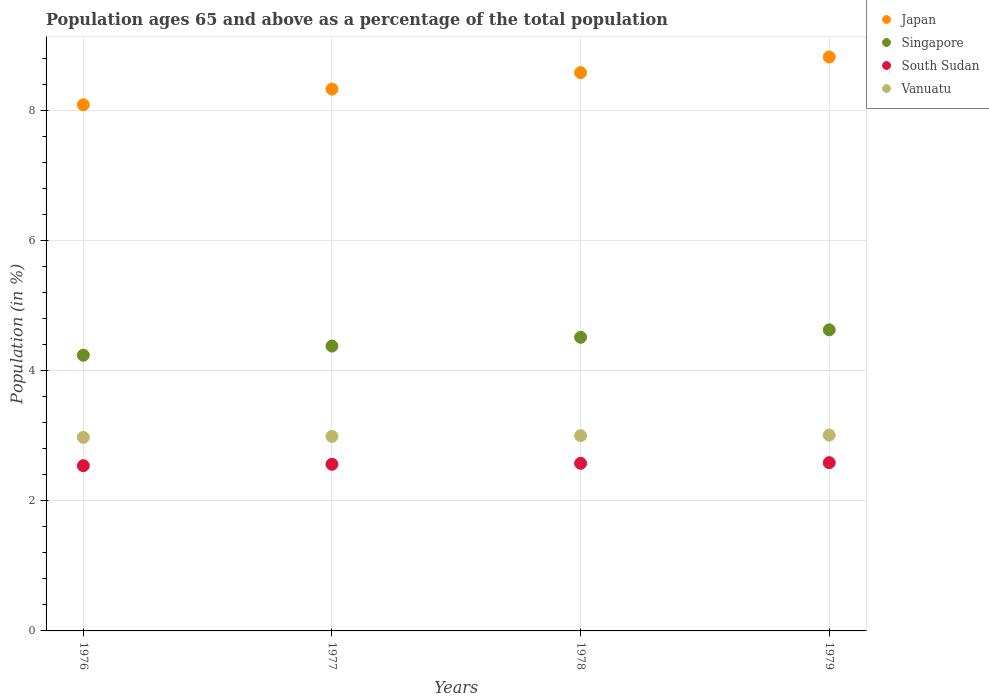How many different coloured dotlines are there?
Keep it short and to the point. 4. What is the percentage of the population ages 65 and above in Vanuatu in 1976?
Your response must be concise. 2.98. Across all years, what is the maximum percentage of the population ages 65 and above in Singapore?
Your answer should be very brief. 4.63. Across all years, what is the minimum percentage of the population ages 65 and above in Japan?
Offer a very short reply. 8.1. In which year was the percentage of the population ages 65 and above in Singapore maximum?
Provide a short and direct response. 1979. In which year was the percentage of the population ages 65 and above in Singapore minimum?
Keep it short and to the point. 1976. What is the total percentage of the population ages 65 and above in Vanuatu in the graph?
Your answer should be compact. 11.99. What is the difference between the percentage of the population ages 65 and above in Vanuatu in 1976 and that in 1977?
Keep it short and to the point. -0.01. What is the difference between the percentage of the population ages 65 and above in South Sudan in 1979 and the percentage of the population ages 65 and above in Singapore in 1978?
Give a very brief answer. -1.93. What is the average percentage of the population ages 65 and above in Singapore per year?
Ensure brevity in your answer.  4.44. In the year 1976, what is the difference between the percentage of the population ages 65 and above in Vanuatu and percentage of the population ages 65 and above in South Sudan?
Your response must be concise. 0.44. In how many years, is the percentage of the population ages 65 and above in Japan greater than 8?
Your response must be concise. 4. What is the ratio of the percentage of the population ages 65 and above in South Sudan in 1977 to that in 1978?
Provide a short and direct response. 0.99. Is the percentage of the population ages 65 and above in South Sudan in 1977 less than that in 1978?
Offer a very short reply. Yes. What is the difference between the highest and the second highest percentage of the population ages 65 and above in South Sudan?
Make the answer very short. 0.01. What is the difference between the highest and the lowest percentage of the population ages 65 and above in Singapore?
Your response must be concise. 0.39. Is it the case that in every year, the sum of the percentage of the population ages 65 and above in Singapore and percentage of the population ages 65 and above in South Sudan  is greater than the sum of percentage of the population ages 65 and above in Japan and percentage of the population ages 65 and above in Vanuatu?
Keep it short and to the point. Yes. Does the percentage of the population ages 65 and above in Japan monotonically increase over the years?
Provide a short and direct response. Yes. Is the percentage of the population ages 65 and above in Japan strictly less than the percentage of the population ages 65 and above in Vanuatu over the years?
Provide a short and direct response. No. How many dotlines are there?
Your answer should be very brief. 4. How many years are there in the graph?
Your answer should be very brief. 4. What is the difference between two consecutive major ticks on the Y-axis?
Keep it short and to the point. 2. Are the values on the major ticks of Y-axis written in scientific E-notation?
Your response must be concise. No. Does the graph contain any zero values?
Ensure brevity in your answer.  No. How are the legend labels stacked?
Ensure brevity in your answer.  Vertical. What is the title of the graph?
Make the answer very short. Population ages 65 and above as a percentage of the total population. Does "Serbia" appear as one of the legend labels in the graph?
Provide a short and direct response. No. What is the label or title of the Y-axis?
Make the answer very short. Population (in %). What is the Population (in %) in Japan in 1976?
Offer a very short reply. 8.1. What is the Population (in %) of Singapore in 1976?
Provide a succinct answer. 4.24. What is the Population (in %) of South Sudan in 1976?
Keep it short and to the point. 2.54. What is the Population (in %) of Vanuatu in 1976?
Make the answer very short. 2.98. What is the Population (in %) in Japan in 1977?
Provide a short and direct response. 8.34. What is the Population (in %) in Singapore in 1977?
Make the answer very short. 4.38. What is the Population (in %) in South Sudan in 1977?
Offer a terse response. 2.56. What is the Population (in %) of Vanuatu in 1977?
Provide a short and direct response. 2.99. What is the Population (in %) in Japan in 1978?
Your answer should be very brief. 8.59. What is the Population (in %) of Singapore in 1978?
Ensure brevity in your answer.  4.52. What is the Population (in %) in South Sudan in 1978?
Make the answer very short. 2.58. What is the Population (in %) in Vanuatu in 1978?
Offer a terse response. 3. What is the Population (in %) of Japan in 1979?
Ensure brevity in your answer.  8.83. What is the Population (in %) of Singapore in 1979?
Ensure brevity in your answer.  4.63. What is the Population (in %) of South Sudan in 1979?
Keep it short and to the point. 2.59. What is the Population (in %) in Vanuatu in 1979?
Your answer should be very brief. 3.01. Across all years, what is the maximum Population (in %) in Japan?
Keep it short and to the point. 8.83. Across all years, what is the maximum Population (in %) of Singapore?
Your response must be concise. 4.63. Across all years, what is the maximum Population (in %) in South Sudan?
Your answer should be very brief. 2.59. Across all years, what is the maximum Population (in %) of Vanuatu?
Give a very brief answer. 3.01. Across all years, what is the minimum Population (in %) of Japan?
Provide a succinct answer. 8.1. Across all years, what is the minimum Population (in %) of Singapore?
Provide a short and direct response. 4.24. Across all years, what is the minimum Population (in %) of South Sudan?
Your response must be concise. 2.54. Across all years, what is the minimum Population (in %) of Vanuatu?
Give a very brief answer. 2.98. What is the total Population (in %) of Japan in the graph?
Keep it short and to the point. 33.85. What is the total Population (in %) in Singapore in the graph?
Provide a succinct answer. 17.78. What is the total Population (in %) of South Sudan in the graph?
Give a very brief answer. 10.27. What is the total Population (in %) of Vanuatu in the graph?
Offer a terse response. 11.99. What is the difference between the Population (in %) of Japan in 1976 and that in 1977?
Provide a succinct answer. -0.24. What is the difference between the Population (in %) in Singapore in 1976 and that in 1977?
Offer a very short reply. -0.14. What is the difference between the Population (in %) in South Sudan in 1976 and that in 1977?
Offer a very short reply. -0.02. What is the difference between the Population (in %) in Vanuatu in 1976 and that in 1977?
Your answer should be compact. -0.01. What is the difference between the Population (in %) of Japan in 1976 and that in 1978?
Give a very brief answer. -0.49. What is the difference between the Population (in %) of Singapore in 1976 and that in 1978?
Your answer should be very brief. -0.28. What is the difference between the Population (in %) in South Sudan in 1976 and that in 1978?
Make the answer very short. -0.04. What is the difference between the Population (in %) in Vanuatu in 1976 and that in 1978?
Offer a very short reply. -0.03. What is the difference between the Population (in %) of Japan in 1976 and that in 1979?
Give a very brief answer. -0.74. What is the difference between the Population (in %) in Singapore in 1976 and that in 1979?
Give a very brief answer. -0.39. What is the difference between the Population (in %) of South Sudan in 1976 and that in 1979?
Make the answer very short. -0.05. What is the difference between the Population (in %) in Vanuatu in 1976 and that in 1979?
Keep it short and to the point. -0.04. What is the difference between the Population (in %) of Japan in 1977 and that in 1978?
Offer a very short reply. -0.25. What is the difference between the Population (in %) of Singapore in 1977 and that in 1978?
Make the answer very short. -0.14. What is the difference between the Population (in %) in South Sudan in 1977 and that in 1978?
Offer a very short reply. -0.02. What is the difference between the Population (in %) of Vanuatu in 1977 and that in 1978?
Your answer should be compact. -0.01. What is the difference between the Population (in %) in Japan in 1977 and that in 1979?
Provide a short and direct response. -0.49. What is the difference between the Population (in %) in Singapore in 1977 and that in 1979?
Provide a short and direct response. -0.25. What is the difference between the Population (in %) of South Sudan in 1977 and that in 1979?
Make the answer very short. -0.03. What is the difference between the Population (in %) of Vanuatu in 1977 and that in 1979?
Your answer should be very brief. -0.02. What is the difference between the Population (in %) in Japan in 1978 and that in 1979?
Provide a short and direct response. -0.24. What is the difference between the Population (in %) in Singapore in 1978 and that in 1979?
Keep it short and to the point. -0.11. What is the difference between the Population (in %) of South Sudan in 1978 and that in 1979?
Provide a short and direct response. -0.01. What is the difference between the Population (in %) in Vanuatu in 1978 and that in 1979?
Offer a very short reply. -0.01. What is the difference between the Population (in %) of Japan in 1976 and the Population (in %) of Singapore in 1977?
Ensure brevity in your answer.  3.71. What is the difference between the Population (in %) in Japan in 1976 and the Population (in %) in South Sudan in 1977?
Provide a succinct answer. 5.53. What is the difference between the Population (in %) of Japan in 1976 and the Population (in %) of Vanuatu in 1977?
Provide a short and direct response. 5.1. What is the difference between the Population (in %) of Singapore in 1976 and the Population (in %) of South Sudan in 1977?
Your response must be concise. 1.68. What is the difference between the Population (in %) in Singapore in 1976 and the Population (in %) in Vanuatu in 1977?
Offer a very short reply. 1.25. What is the difference between the Population (in %) in South Sudan in 1976 and the Population (in %) in Vanuatu in 1977?
Keep it short and to the point. -0.45. What is the difference between the Population (in %) of Japan in 1976 and the Population (in %) of Singapore in 1978?
Offer a terse response. 3.58. What is the difference between the Population (in %) of Japan in 1976 and the Population (in %) of South Sudan in 1978?
Give a very brief answer. 5.52. What is the difference between the Population (in %) in Japan in 1976 and the Population (in %) in Vanuatu in 1978?
Your answer should be very brief. 5.09. What is the difference between the Population (in %) of Singapore in 1976 and the Population (in %) of South Sudan in 1978?
Offer a terse response. 1.66. What is the difference between the Population (in %) of Singapore in 1976 and the Population (in %) of Vanuatu in 1978?
Your answer should be very brief. 1.24. What is the difference between the Population (in %) in South Sudan in 1976 and the Population (in %) in Vanuatu in 1978?
Ensure brevity in your answer.  -0.46. What is the difference between the Population (in %) in Japan in 1976 and the Population (in %) in Singapore in 1979?
Your response must be concise. 3.46. What is the difference between the Population (in %) in Japan in 1976 and the Population (in %) in South Sudan in 1979?
Offer a terse response. 5.51. What is the difference between the Population (in %) in Japan in 1976 and the Population (in %) in Vanuatu in 1979?
Give a very brief answer. 5.08. What is the difference between the Population (in %) in Singapore in 1976 and the Population (in %) in South Sudan in 1979?
Your answer should be compact. 1.65. What is the difference between the Population (in %) of Singapore in 1976 and the Population (in %) of Vanuatu in 1979?
Ensure brevity in your answer.  1.23. What is the difference between the Population (in %) in South Sudan in 1976 and the Population (in %) in Vanuatu in 1979?
Ensure brevity in your answer.  -0.47. What is the difference between the Population (in %) of Japan in 1977 and the Population (in %) of Singapore in 1978?
Offer a terse response. 3.82. What is the difference between the Population (in %) of Japan in 1977 and the Population (in %) of South Sudan in 1978?
Ensure brevity in your answer.  5.76. What is the difference between the Population (in %) of Japan in 1977 and the Population (in %) of Vanuatu in 1978?
Offer a very short reply. 5.33. What is the difference between the Population (in %) in Singapore in 1977 and the Population (in %) in South Sudan in 1978?
Give a very brief answer. 1.8. What is the difference between the Population (in %) in Singapore in 1977 and the Population (in %) in Vanuatu in 1978?
Provide a short and direct response. 1.38. What is the difference between the Population (in %) in South Sudan in 1977 and the Population (in %) in Vanuatu in 1978?
Your response must be concise. -0.44. What is the difference between the Population (in %) in Japan in 1977 and the Population (in %) in Singapore in 1979?
Offer a terse response. 3.7. What is the difference between the Population (in %) of Japan in 1977 and the Population (in %) of South Sudan in 1979?
Your response must be concise. 5.75. What is the difference between the Population (in %) in Japan in 1977 and the Population (in %) in Vanuatu in 1979?
Your response must be concise. 5.32. What is the difference between the Population (in %) of Singapore in 1977 and the Population (in %) of South Sudan in 1979?
Provide a short and direct response. 1.79. What is the difference between the Population (in %) in Singapore in 1977 and the Population (in %) in Vanuatu in 1979?
Ensure brevity in your answer.  1.37. What is the difference between the Population (in %) of South Sudan in 1977 and the Population (in %) of Vanuatu in 1979?
Your answer should be compact. -0.45. What is the difference between the Population (in %) of Japan in 1978 and the Population (in %) of Singapore in 1979?
Offer a very short reply. 3.96. What is the difference between the Population (in %) of Japan in 1978 and the Population (in %) of South Sudan in 1979?
Ensure brevity in your answer.  6. What is the difference between the Population (in %) of Japan in 1978 and the Population (in %) of Vanuatu in 1979?
Provide a succinct answer. 5.58. What is the difference between the Population (in %) in Singapore in 1978 and the Population (in %) in South Sudan in 1979?
Make the answer very short. 1.93. What is the difference between the Population (in %) of Singapore in 1978 and the Population (in %) of Vanuatu in 1979?
Ensure brevity in your answer.  1.51. What is the difference between the Population (in %) of South Sudan in 1978 and the Population (in %) of Vanuatu in 1979?
Your response must be concise. -0.43. What is the average Population (in %) in Japan per year?
Your answer should be very brief. 8.46. What is the average Population (in %) of Singapore per year?
Provide a succinct answer. 4.44. What is the average Population (in %) in South Sudan per year?
Provide a short and direct response. 2.57. What is the average Population (in %) of Vanuatu per year?
Keep it short and to the point. 3. In the year 1976, what is the difference between the Population (in %) in Japan and Population (in %) in Singapore?
Make the answer very short. 3.85. In the year 1976, what is the difference between the Population (in %) of Japan and Population (in %) of South Sudan?
Provide a short and direct response. 5.55. In the year 1976, what is the difference between the Population (in %) in Japan and Population (in %) in Vanuatu?
Offer a terse response. 5.12. In the year 1976, what is the difference between the Population (in %) of Singapore and Population (in %) of South Sudan?
Make the answer very short. 1.7. In the year 1976, what is the difference between the Population (in %) in Singapore and Population (in %) in Vanuatu?
Provide a succinct answer. 1.26. In the year 1976, what is the difference between the Population (in %) of South Sudan and Population (in %) of Vanuatu?
Your answer should be compact. -0.44. In the year 1977, what is the difference between the Population (in %) of Japan and Population (in %) of Singapore?
Your answer should be compact. 3.95. In the year 1977, what is the difference between the Population (in %) in Japan and Population (in %) in South Sudan?
Your response must be concise. 5.77. In the year 1977, what is the difference between the Population (in %) in Japan and Population (in %) in Vanuatu?
Give a very brief answer. 5.34. In the year 1977, what is the difference between the Population (in %) in Singapore and Population (in %) in South Sudan?
Offer a terse response. 1.82. In the year 1977, what is the difference between the Population (in %) in Singapore and Population (in %) in Vanuatu?
Your response must be concise. 1.39. In the year 1977, what is the difference between the Population (in %) of South Sudan and Population (in %) of Vanuatu?
Offer a very short reply. -0.43. In the year 1978, what is the difference between the Population (in %) of Japan and Population (in %) of Singapore?
Offer a very short reply. 4.07. In the year 1978, what is the difference between the Population (in %) of Japan and Population (in %) of South Sudan?
Offer a very short reply. 6.01. In the year 1978, what is the difference between the Population (in %) in Japan and Population (in %) in Vanuatu?
Your response must be concise. 5.59. In the year 1978, what is the difference between the Population (in %) in Singapore and Population (in %) in South Sudan?
Ensure brevity in your answer.  1.94. In the year 1978, what is the difference between the Population (in %) of Singapore and Population (in %) of Vanuatu?
Make the answer very short. 1.51. In the year 1978, what is the difference between the Population (in %) in South Sudan and Population (in %) in Vanuatu?
Give a very brief answer. -0.43. In the year 1979, what is the difference between the Population (in %) of Japan and Population (in %) of Singapore?
Offer a very short reply. 4.2. In the year 1979, what is the difference between the Population (in %) of Japan and Population (in %) of South Sudan?
Your answer should be compact. 6.24. In the year 1979, what is the difference between the Population (in %) of Japan and Population (in %) of Vanuatu?
Offer a very short reply. 5.82. In the year 1979, what is the difference between the Population (in %) of Singapore and Population (in %) of South Sudan?
Your answer should be compact. 2.04. In the year 1979, what is the difference between the Population (in %) in Singapore and Population (in %) in Vanuatu?
Your response must be concise. 1.62. In the year 1979, what is the difference between the Population (in %) of South Sudan and Population (in %) of Vanuatu?
Ensure brevity in your answer.  -0.42. What is the ratio of the Population (in %) in Japan in 1976 to that in 1977?
Ensure brevity in your answer.  0.97. What is the ratio of the Population (in %) in Singapore in 1976 to that in 1977?
Give a very brief answer. 0.97. What is the ratio of the Population (in %) in South Sudan in 1976 to that in 1977?
Ensure brevity in your answer.  0.99. What is the ratio of the Population (in %) in Vanuatu in 1976 to that in 1977?
Offer a very short reply. 1. What is the ratio of the Population (in %) in Japan in 1976 to that in 1978?
Your answer should be very brief. 0.94. What is the ratio of the Population (in %) of Singapore in 1976 to that in 1978?
Provide a succinct answer. 0.94. What is the ratio of the Population (in %) of South Sudan in 1976 to that in 1978?
Ensure brevity in your answer.  0.99. What is the ratio of the Population (in %) of Vanuatu in 1976 to that in 1978?
Your answer should be compact. 0.99. What is the ratio of the Population (in %) of Singapore in 1976 to that in 1979?
Your answer should be very brief. 0.92. What is the ratio of the Population (in %) in South Sudan in 1976 to that in 1979?
Give a very brief answer. 0.98. What is the ratio of the Population (in %) of Vanuatu in 1976 to that in 1979?
Offer a very short reply. 0.99. What is the ratio of the Population (in %) in Japan in 1977 to that in 1978?
Make the answer very short. 0.97. What is the ratio of the Population (in %) of Singapore in 1977 to that in 1978?
Provide a succinct answer. 0.97. What is the ratio of the Population (in %) of South Sudan in 1977 to that in 1978?
Your answer should be compact. 0.99. What is the ratio of the Population (in %) of Vanuatu in 1977 to that in 1978?
Your answer should be compact. 1. What is the ratio of the Population (in %) in Japan in 1977 to that in 1979?
Offer a very short reply. 0.94. What is the ratio of the Population (in %) of Singapore in 1977 to that in 1979?
Keep it short and to the point. 0.95. What is the ratio of the Population (in %) of South Sudan in 1977 to that in 1979?
Provide a succinct answer. 0.99. What is the ratio of the Population (in %) in Vanuatu in 1977 to that in 1979?
Make the answer very short. 0.99. What is the ratio of the Population (in %) of Japan in 1978 to that in 1979?
Provide a short and direct response. 0.97. What is the ratio of the Population (in %) in Singapore in 1978 to that in 1979?
Your answer should be very brief. 0.98. What is the ratio of the Population (in %) of South Sudan in 1978 to that in 1979?
Ensure brevity in your answer.  1. What is the difference between the highest and the second highest Population (in %) in Japan?
Keep it short and to the point. 0.24. What is the difference between the highest and the second highest Population (in %) in Singapore?
Keep it short and to the point. 0.11. What is the difference between the highest and the second highest Population (in %) of South Sudan?
Your answer should be very brief. 0.01. What is the difference between the highest and the second highest Population (in %) in Vanuatu?
Make the answer very short. 0.01. What is the difference between the highest and the lowest Population (in %) in Japan?
Provide a short and direct response. 0.74. What is the difference between the highest and the lowest Population (in %) of Singapore?
Your answer should be compact. 0.39. What is the difference between the highest and the lowest Population (in %) in South Sudan?
Your response must be concise. 0.05. What is the difference between the highest and the lowest Population (in %) in Vanuatu?
Your response must be concise. 0.04. 